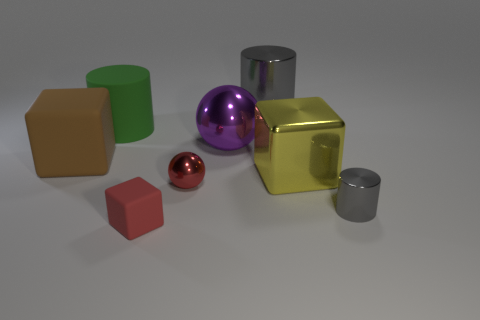How many gray cylinders must be subtracted to get 1 gray cylinders? 1 Subtract all red cubes. How many cubes are left? 2 Add 2 yellow metallic things. How many objects exist? 10 Subtract all green spheres. How many gray cylinders are left? 2 Subtract 1 cylinders. How many cylinders are left? 2 Subtract all green cylinders. How many cylinders are left? 2 Subtract all cubes. How many objects are left? 5 Add 5 large blocks. How many large blocks are left? 7 Add 5 tiny brown blocks. How many tiny brown blocks exist? 5 Subtract 0 purple cubes. How many objects are left? 8 